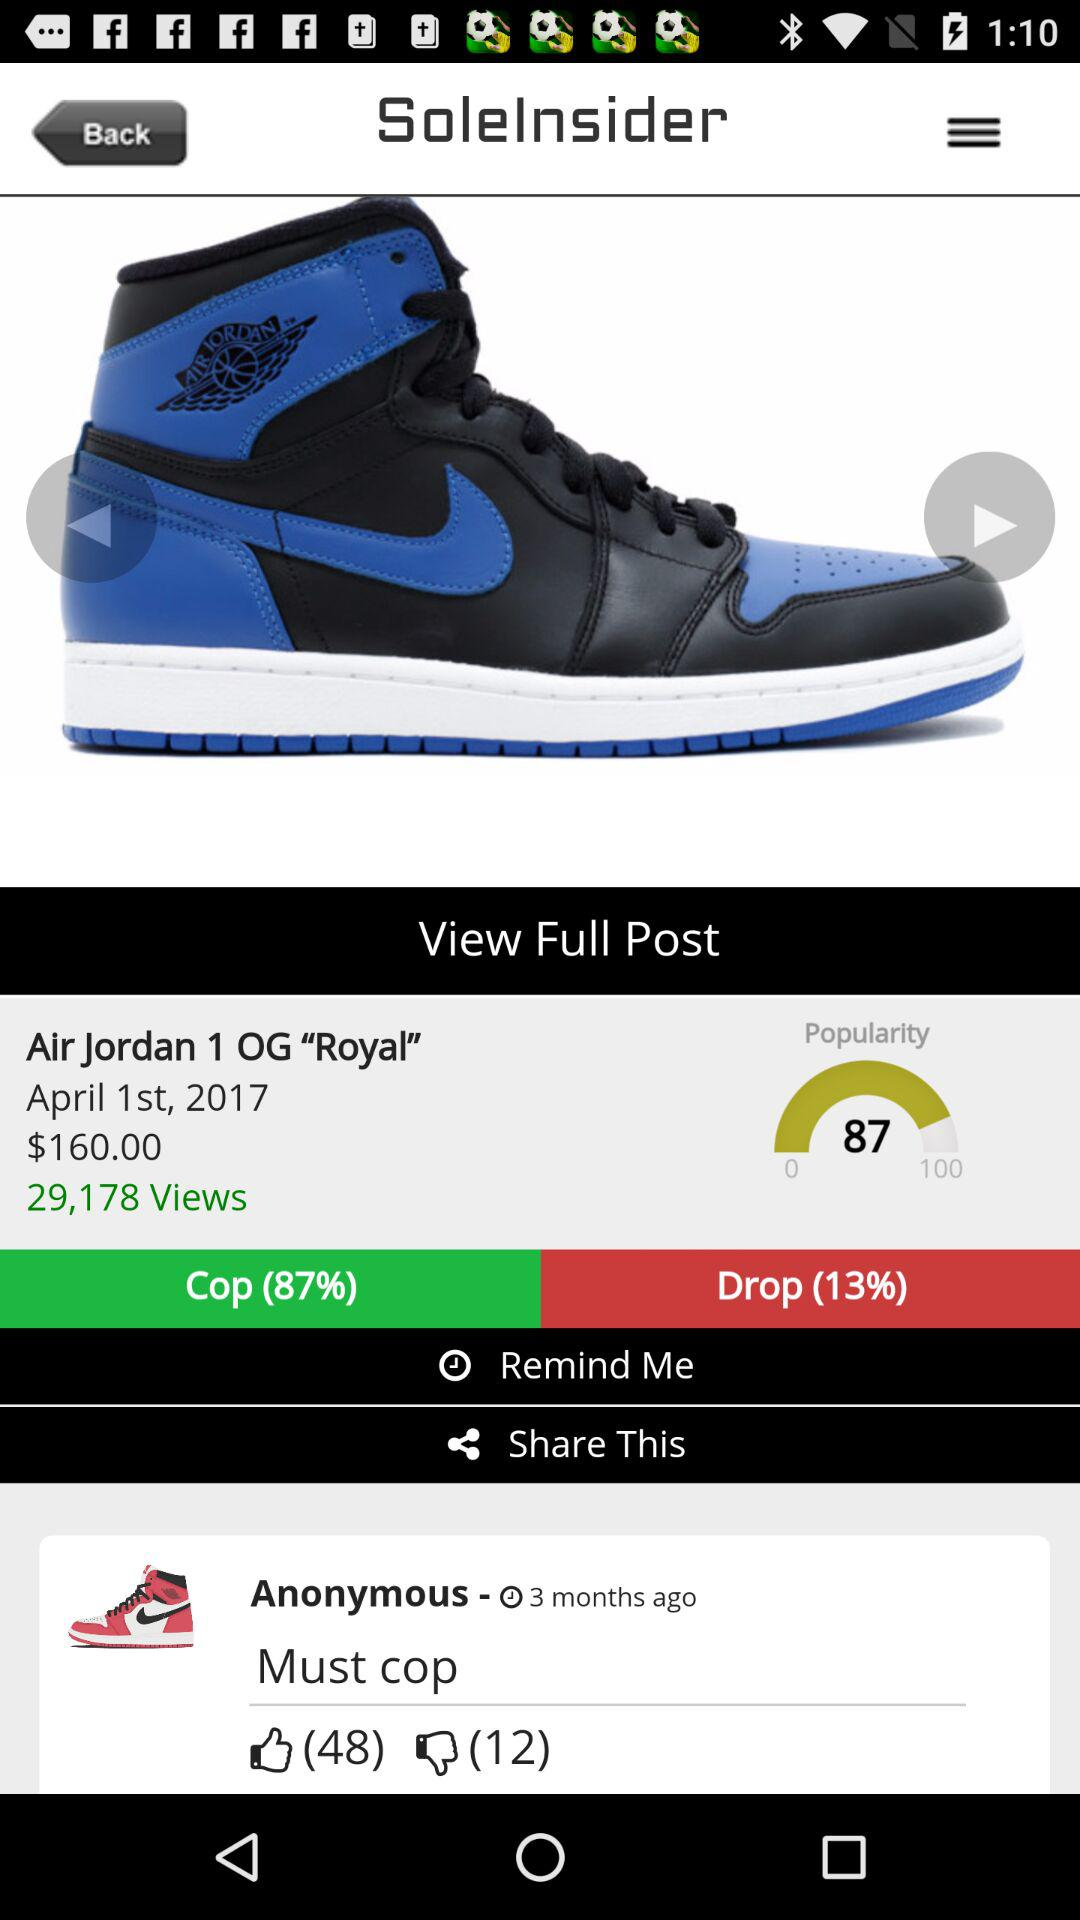What is the price of the "Air Jordan 1 OG "Royal""? The price is $160. 